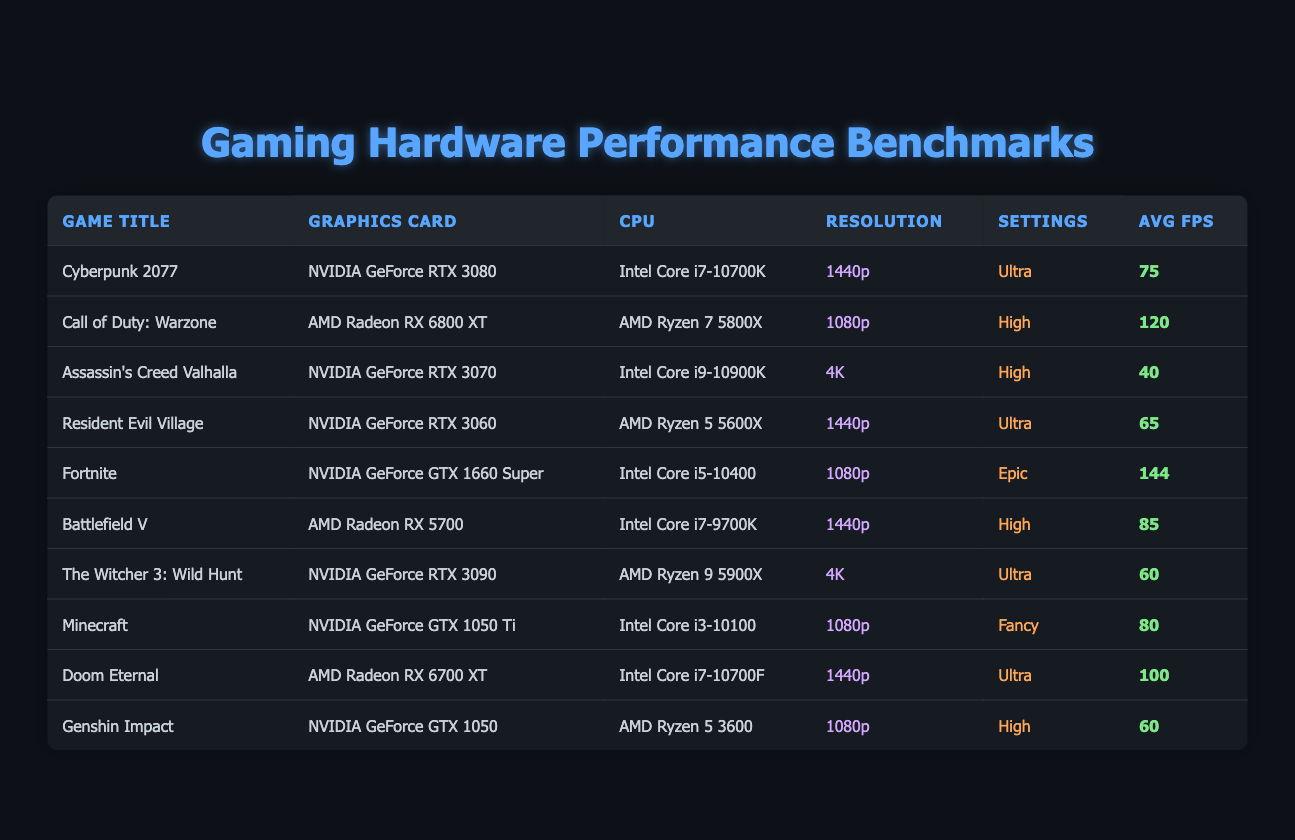What is the average FPS for Cyberpunk 2077? The table lists Cyberpunk 2077 under "Avg FPS" as 75. Therefore, the average FPS for this game is simply the value provided in the table.
Answer: 75 Which game has the highest average FPS? Looking through the "Avg FPS" column, Fortnite has the highest value at 144 FPS compared to other titles.
Answer: Fortnite Is the resolution of Assassin's Creed Valhalla higher than that of Fortnite? Assassin's Creed Valhalla is listed at 4K resolution, while Fortnite is at 1080p. Since 4K is superior to 1080p, the answer is yes.
Answer: Yes What settings are used for Doom Eternal? Doom Eternal is played at "Ultra" settings as mentioned in the settings column of the table.
Answer: Ultra How many games have an average FPS of 60 or higher? The games with average FPS of 60 or higher are: Call of Duty: Warzone (120), Fortnite (144), Doom Eternal (100), Battlefield V (85), Cyberpunk 2077 (75), Resident Evil Village (65), and The Witcher 3: Wild Hunt (60). There are 7 games total.
Answer: 7 What is the difference in average FPS between Call of Duty: Warzone and Cyberpunk 2077? Call of Duty: Warzone has an average FPS of 120, and Cyberpunk 2077 has an average FPS of 75. The difference is calculated by subtracting: 120 - 75 = 45.
Answer: 45 Which graphics card is used in the game with the lowest average FPS? The game with the lowest average FPS is Assassin's Creed Valhalla, with an average FPS of 40. It uses the NVIDIA GeForce RTX 3070 as its graphics card.
Answer: NVIDIA GeForce RTX 3070 How many games use NVIDIA graphics cards? The listed NVIDIA graphics cards are used in the following games: Cyberpunk 2077, Assassin's Creed Valhalla, Resident Evil Village, The Witcher 3: Wild Hunt, Minecraft, and Doom Eternal. This totals to 6 games.
Answer: 6 Is there a game with 1440p resolution that has an average FPS lower than 75? Resident Evil Village is played at 1440p and has an average FPS of 65, which is lower than 75. Therefore, the answer is yes.
Answer: Yes What is the average FPS for games played at 1080p resolution? The games played at 1080p are Call of Duty: Warzone (120), Fortnite (144), Minecraft (80), and Genshin Impact (60). Calculating the average: (120 + 144 + 80 + 60) / 4 = 102.
Answer: 102 Which CPU is common in games with average FPS of 80 or higher? The games with average FPS of 80 or higher include Call of Duty: Warzone (AMD Ryzen 7 5800X), Fortnite (Intel Core i5-10400), Doom Eternal (Intel Core i7-10700F), Battlefield V (Intel Core i7-9700K), and Cyberpunk 2077 (Intel Core i7-10700K). The CPUs used vary, with no single CPU appearing in all high FPS games; thus, there is no common CPU.
Answer: None 